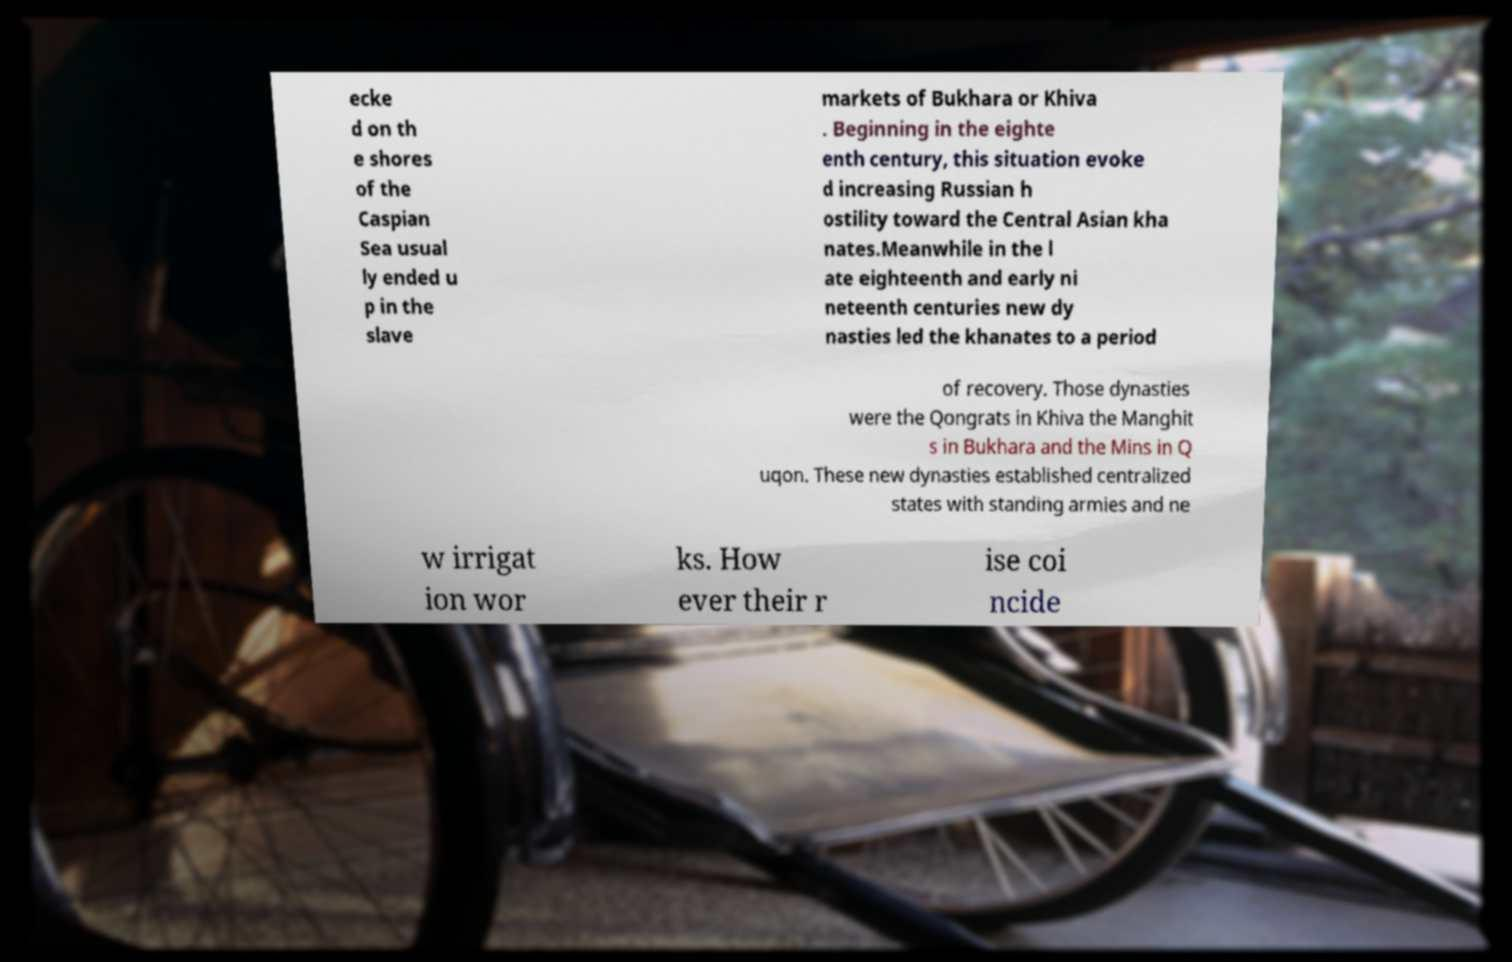Please read and relay the text visible in this image. What does it say? ecke d on th e shores of the Caspian Sea usual ly ended u p in the slave markets of Bukhara or Khiva . Beginning in the eighte enth century, this situation evoke d increasing Russian h ostility toward the Central Asian kha nates.Meanwhile in the l ate eighteenth and early ni neteenth centuries new dy nasties led the khanates to a period of recovery. Those dynasties were the Qongrats in Khiva the Manghit s in Bukhara and the Mins in Q uqon. These new dynasties established centralized states with standing armies and ne w irrigat ion wor ks. How ever their r ise coi ncide 